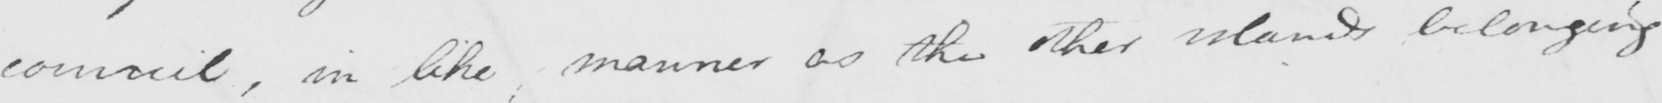Please transcribe the handwritten text in this image. council , in like manner as the other islands belonging 